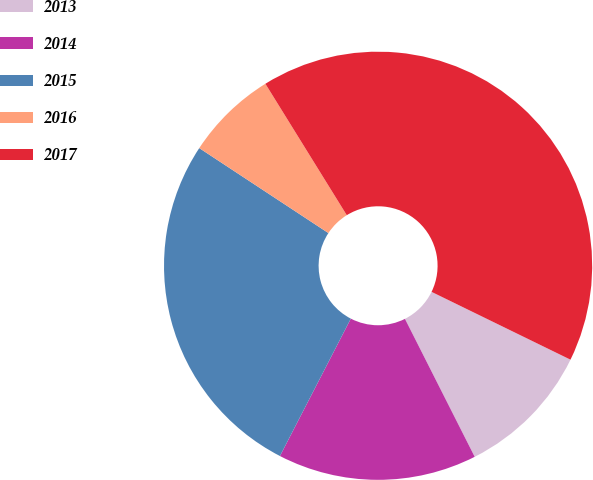Convert chart. <chart><loc_0><loc_0><loc_500><loc_500><pie_chart><fcel>2013<fcel>2014<fcel>2015<fcel>2016<fcel>2017<nl><fcel>10.32%<fcel>15.03%<fcel>26.68%<fcel>6.91%<fcel>41.05%<nl></chart> 